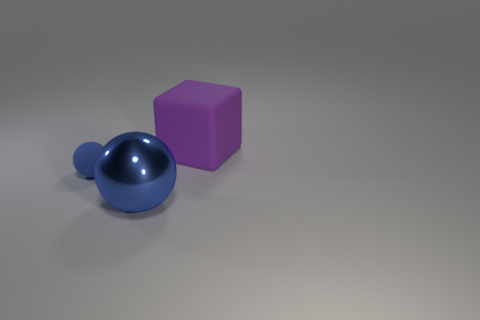Add 3 purple matte objects. How many objects exist? 6 Subtract all cubes. How many objects are left? 2 Subtract 2 balls. How many balls are left? 0 Subtract all purple cubes. Subtract all big blue metallic balls. How many objects are left? 1 Add 2 blue matte objects. How many blue matte objects are left? 3 Add 2 purple rubber things. How many purple rubber things exist? 3 Subtract 0 red cubes. How many objects are left? 3 